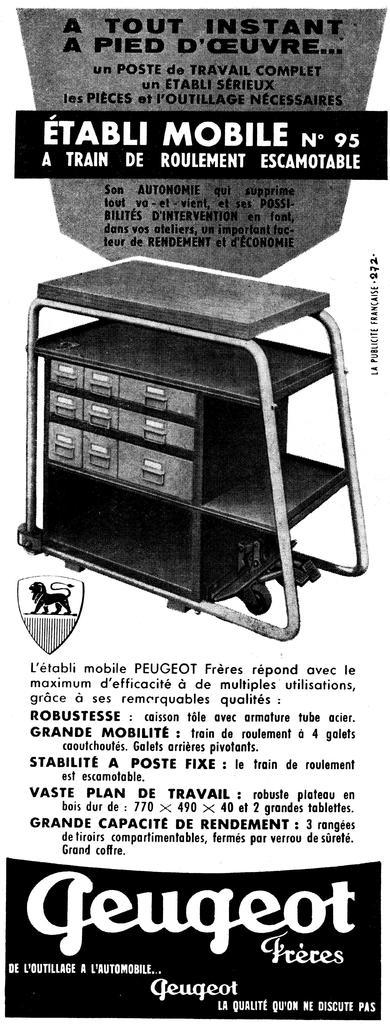Provide a one-sentence caption for the provided image. old black and white ad for geugeot freces mobile cart. 